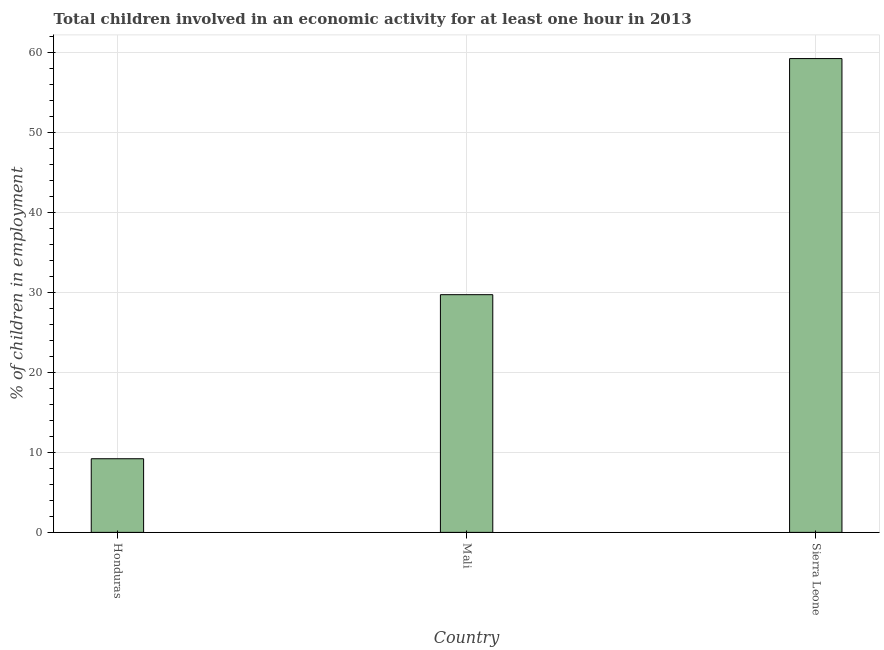Does the graph contain any zero values?
Provide a short and direct response. No. What is the title of the graph?
Provide a succinct answer. Total children involved in an economic activity for at least one hour in 2013. What is the label or title of the X-axis?
Your answer should be compact. Country. What is the label or title of the Y-axis?
Give a very brief answer. % of children in employment. What is the percentage of children in employment in Honduras?
Make the answer very short. 9.2. Across all countries, what is the maximum percentage of children in employment?
Your answer should be compact. 59.2. Across all countries, what is the minimum percentage of children in employment?
Offer a very short reply. 9.2. In which country was the percentage of children in employment maximum?
Offer a very short reply. Sierra Leone. In which country was the percentage of children in employment minimum?
Your answer should be very brief. Honduras. What is the sum of the percentage of children in employment?
Ensure brevity in your answer.  98.1. What is the difference between the percentage of children in employment in Mali and Sierra Leone?
Keep it short and to the point. -29.5. What is the average percentage of children in employment per country?
Offer a very short reply. 32.7. What is the median percentage of children in employment?
Provide a succinct answer. 29.7. What is the ratio of the percentage of children in employment in Honduras to that in Mali?
Offer a very short reply. 0.31. Is the percentage of children in employment in Honduras less than that in Mali?
Provide a short and direct response. Yes. What is the difference between the highest and the second highest percentage of children in employment?
Make the answer very short. 29.5. Is the sum of the percentage of children in employment in Mali and Sierra Leone greater than the maximum percentage of children in employment across all countries?
Your answer should be very brief. Yes. In how many countries, is the percentage of children in employment greater than the average percentage of children in employment taken over all countries?
Provide a succinct answer. 1. Are all the bars in the graph horizontal?
Make the answer very short. No. Are the values on the major ticks of Y-axis written in scientific E-notation?
Your answer should be very brief. No. What is the % of children in employment of Honduras?
Provide a succinct answer. 9.2. What is the % of children in employment in Mali?
Your answer should be compact. 29.7. What is the % of children in employment of Sierra Leone?
Make the answer very short. 59.2. What is the difference between the % of children in employment in Honduras and Mali?
Offer a very short reply. -20.5. What is the difference between the % of children in employment in Mali and Sierra Leone?
Provide a short and direct response. -29.5. What is the ratio of the % of children in employment in Honduras to that in Mali?
Provide a short and direct response. 0.31. What is the ratio of the % of children in employment in Honduras to that in Sierra Leone?
Provide a succinct answer. 0.15. What is the ratio of the % of children in employment in Mali to that in Sierra Leone?
Your answer should be very brief. 0.5. 